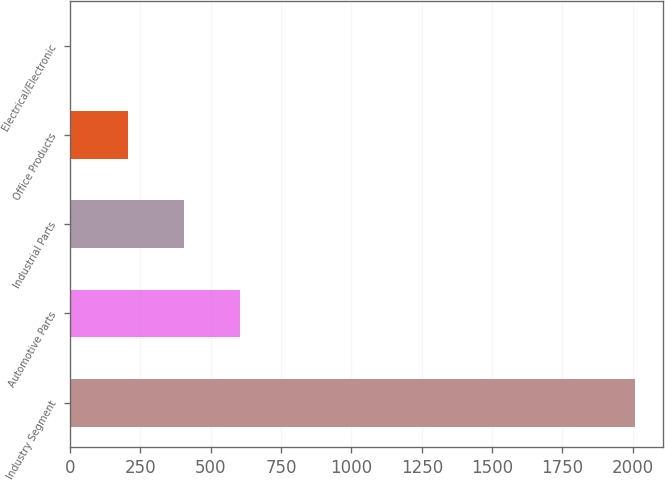Convert chart. <chart><loc_0><loc_0><loc_500><loc_500><bar_chart><fcel>Industry Segment<fcel>Automotive Parts<fcel>Industrial Parts<fcel>Office Products<fcel>Electrical/Electronic<nl><fcel>2008<fcel>605.2<fcel>404.8<fcel>204.4<fcel>4<nl></chart> 